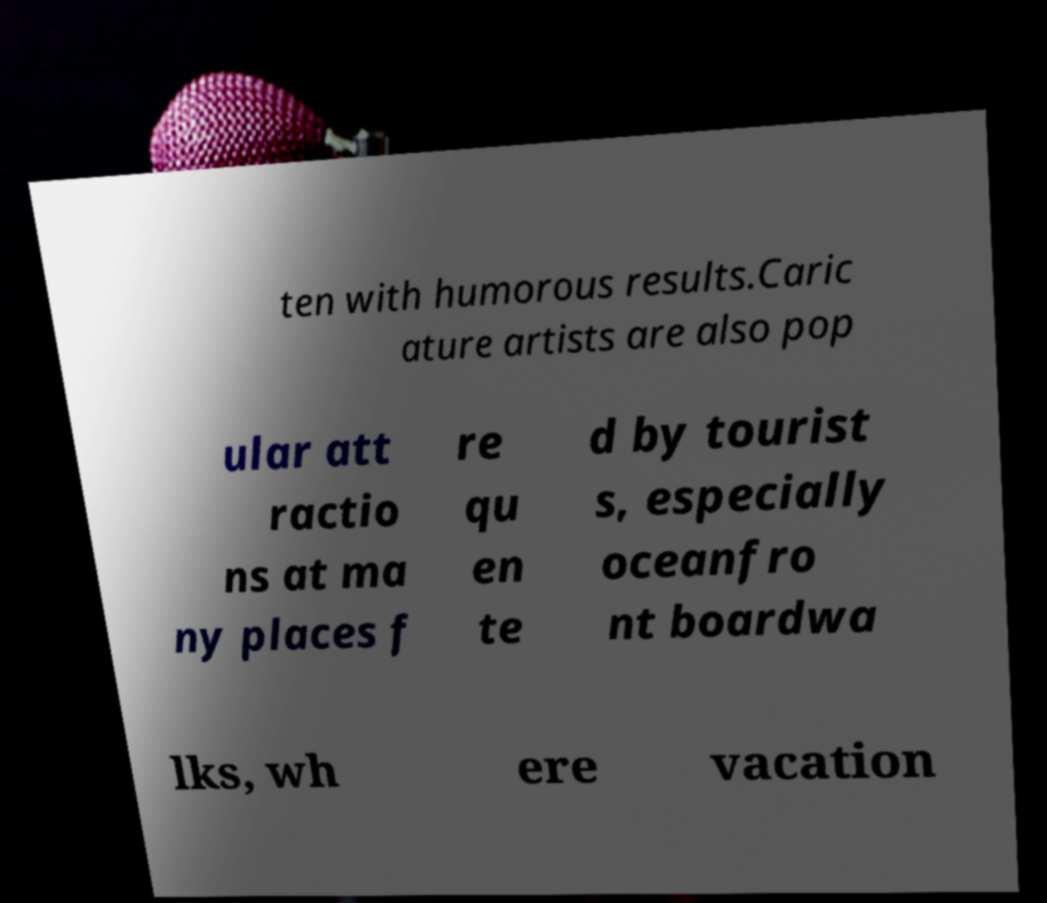I need the written content from this picture converted into text. Can you do that? ten with humorous results.Caric ature artists are also pop ular att ractio ns at ma ny places f re qu en te d by tourist s, especially oceanfro nt boardwa lks, wh ere vacation 